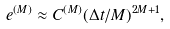Convert formula to latex. <formula><loc_0><loc_0><loc_500><loc_500>e ^ { ( M ) } \approx C ^ { ( M ) } ( \Delta t / M ) ^ { 2 M + 1 } ,</formula> 